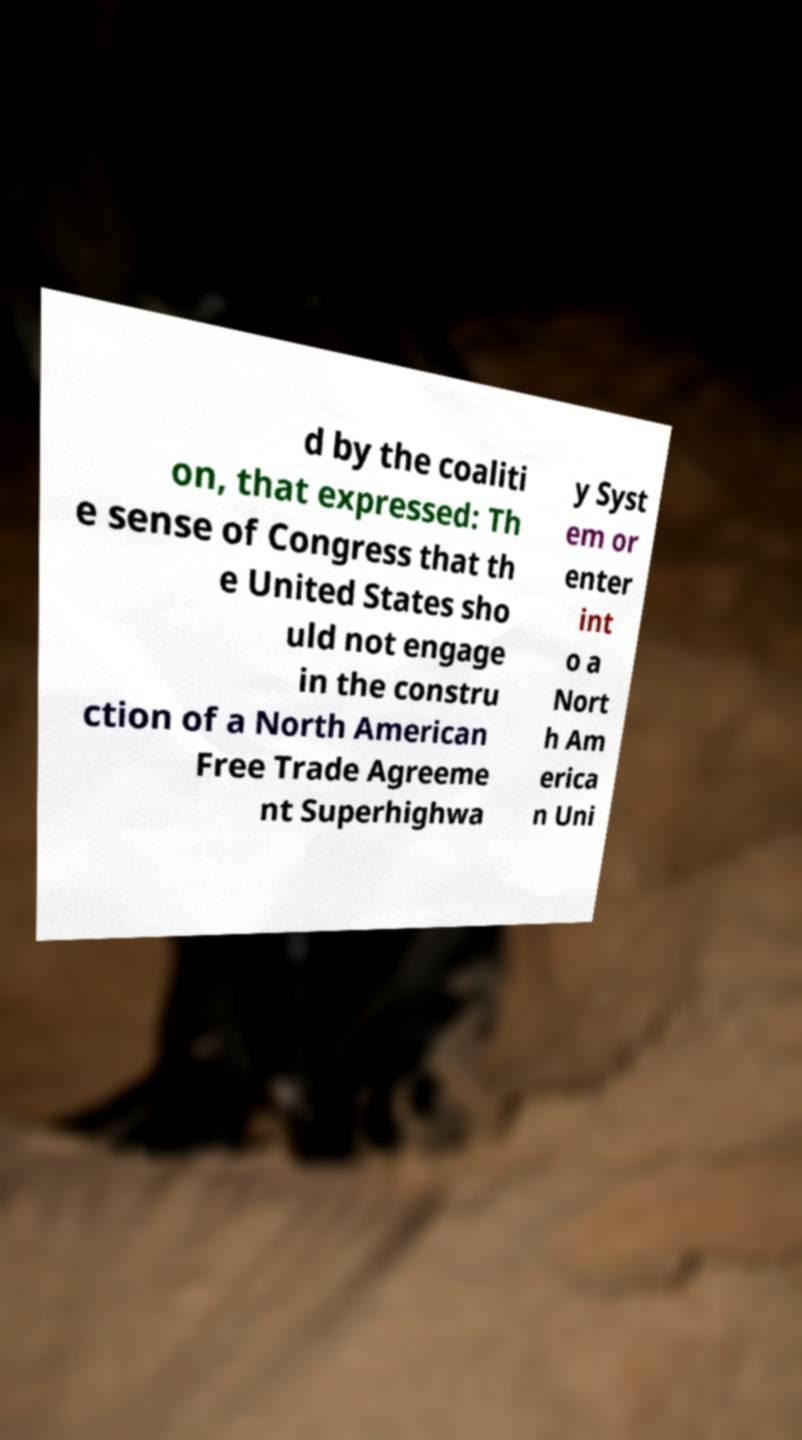Please read and relay the text visible in this image. What does it say? d by the coaliti on, that expressed: Th e sense of Congress that th e United States sho uld not engage in the constru ction of a North American Free Trade Agreeme nt Superhighwa y Syst em or enter int o a Nort h Am erica n Uni 